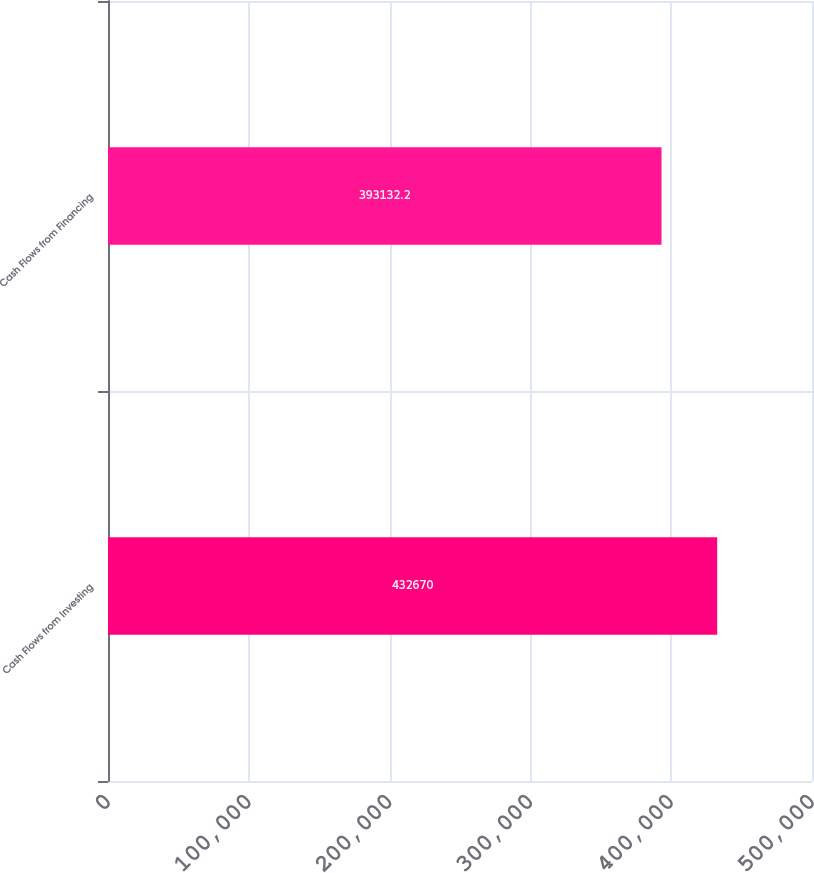Convert chart. <chart><loc_0><loc_0><loc_500><loc_500><bar_chart><fcel>Cash Flows from Investing<fcel>Cash Flows from Financing<nl><fcel>432670<fcel>393132<nl></chart> 